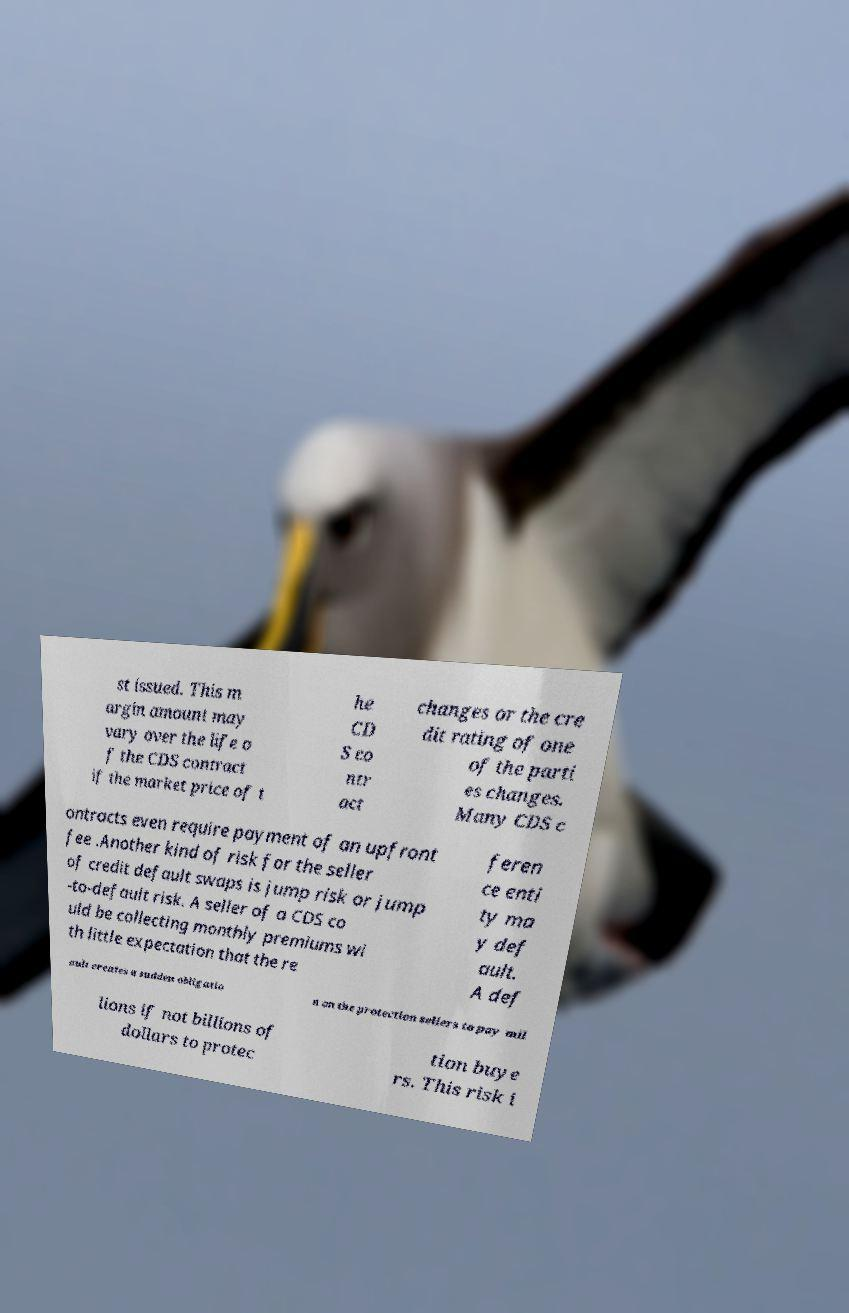Could you assist in decoding the text presented in this image and type it out clearly? st issued. This m argin amount may vary over the life o f the CDS contract if the market price of t he CD S co ntr act changes or the cre dit rating of one of the parti es changes. Many CDS c ontracts even require payment of an upfront fee .Another kind of risk for the seller of credit default swaps is jump risk or jump -to-default risk. A seller of a CDS co uld be collecting monthly premiums wi th little expectation that the re feren ce enti ty ma y def ault. A def ault creates a sudden obligatio n on the protection sellers to pay mil lions if not billions of dollars to protec tion buye rs. This risk i 